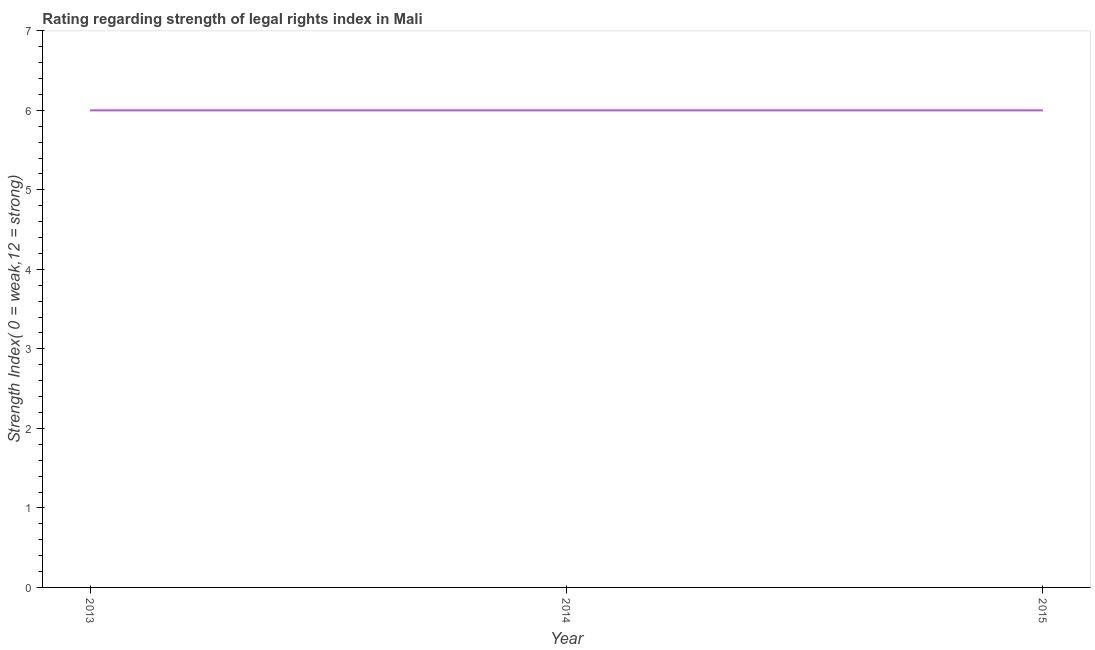What is the strength of legal rights index in 2013?
Offer a very short reply. 6. Across all years, what is the maximum strength of legal rights index?
Make the answer very short. 6. Across all years, what is the minimum strength of legal rights index?
Offer a very short reply. 6. In which year was the strength of legal rights index maximum?
Offer a terse response. 2013. In which year was the strength of legal rights index minimum?
Offer a very short reply. 2013. What is the sum of the strength of legal rights index?
Provide a succinct answer. 18. What is the difference between the strength of legal rights index in 2013 and 2015?
Provide a succinct answer. 0. What is the average strength of legal rights index per year?
Offer a very short reply. 6. What is the median strength of legal rights index?
Your answer should be very brief. 6. Is the strength of legal rights index in 2013 less than that in 2015?
Make the answer very short. No. What is the difference between the highest and the second highest strength of legal rights index?
Your answer should be very brief. 0. In how many years, is the strength of legal rights index greater than the average strength of legal rights index taken over all years?
Ensure brevity in your answer.  0. How many years are there in the graph?
Ensure brevity in your answer.  3. What is the difference between two consecutive major ticks on the Y-axis?
Offer a terse response. 1. Does the graph contain any zero values?
Offer a very short reply. No. What is the title of the graph?
Make the answer very short. Rating regarding strength of legal rights index in Mali. What is the label or title of the Y-axis?
Your answer should be compact. Strength Index( 0 = weak,12 = strong). What is the Strength Index( 0 = weak,12 = strong) in 2013?
Keep it short and to the point. 6. What is the Strength Index( 0 = weak,12 = strong) of 2015?
Make the answer very short. 6. What is the ratio of the Strength Index( 0 = weak,12 = strong) in 2013 to that in 2014?
Ensure brevity in your answer.  1. What is the ratio of the Strength Index( 0 = weak,12 = strong) in 2013 to that in 2015?
Make the answer very short. 1. 